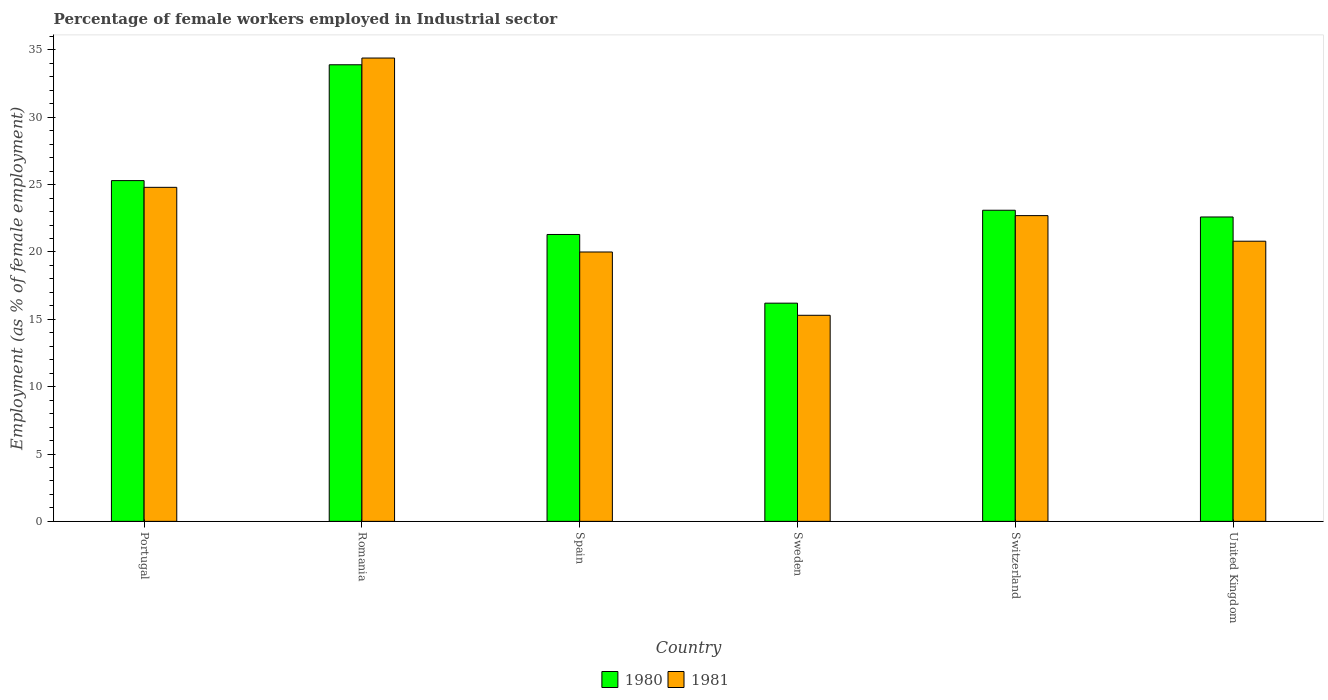How many groups of bars are there?
Provide a succinct answer. 6. Are the number of bars per tick equal to the number of legend labels?
Offer a terse response. Yes. Are the number of bars on each tick of the X-axis equal?
Ensure brevity in your answer.  Yes. What is the label of the 5th group of bars from the left?
Provide a succinct answer. Switzerland. What is the percentage of females employed in Industrial sector in 1980 in Romania?
Make the answer very short. 33.9. Across all countries, what is the maximum percentage of females employed in Industrial sector in 1981?
Make the answer very short. 34.4. Across all countries, what is the minimum percentage of females employed in Industrial sector in 1981?
Your answer should be compact. 15.3. In which country was the percentage of females employed in Industrial sector in 1980 maximum?
Keep it short and to the point. Romania. In which country was the percentage of females employed in Industrial sector in 1981 minimum?
Your answer should be very brief. Sweden. What is the total percentage of females employed in Industrial sector in 1981 in the graph?
Give a very brief answer. 138. What is the difference between the percentage of females employed in Industrial sector in 1981 in Portugal and that in Spain?
Make the answer very short. 4.8. What is the difference between the percentage of females employed in Industrial sector in 1981 in Sweden and the percentage of females employed in Industrial sector in 1980 in Romania?
Offer a very short reply. -18.6. What is the average percentage of females employed in Industrial sector in 1980 per country?
Your answer should be very brief. 23.73. What is the difference between the percentage of females employed in Industrial sector of/in 1980 and percentage of females employed in Industrial sector of/in 1981 in Sweden?
Keep it short and to the point. 0.9. In how many countries, is the percentage of females employed in Industrial sector in 1980 greater than 8 %?
Your response must be concise. 6. What is the ratio of the percentage of females employed in Industrial sector in 1981 in Portugal to that in Spain?
Offer a very short reply. 1.24. Is the percentage of females employed in Industrial sector in 1980 in Sweden less than that in United Kingdom?
Your answer should be very brief. Yes. What is the difference between the highest and the second highest percentage of females employed in Industrial sector in 1980?
Your response must be concise. 8.6. What is the difference between the highest and the lowest percentage of females employed in Industrial sector in 1980?
Make the answer very short. 17.7. Is the sum of the percentage of females employed in Industrial sector in 1980 in Portugal and Switzerland greater than the maximum percentage of females employed in Industrial sector in 1981 across all countries?
Your response must be concise. Yes. What does the 1st bar from the right in Switzerland represents?
Your answer should be very brief. 1981. Are all the bars in the graph horizontal?
Offer a terse response. No. How many countries are there in the graph?
Offer a terse response. 6. What is the difference between two consecutive major ticks on the Y-axis?
Your response must be concise. 5. Does the graph contain grids?
Provide a succinct answer. No. Where does the legend appear in the graph?
Make the answer very short. Bottom center. How are the legend labels stacked?
Provide a short and direct response. Horizontal. What is the title of the graph?
Provide a short and direct response. Percentage of female workers employed in Industrial sector. What is the label or title of the Y-axis?
Your response must be concise. Employment (as % of female employment). What is the Employment (as % of female employment) in 1980 in Portugal?
Make the answer very short. 25.3. What is the Employment (as % of female employment) in 1981 in Portugal?
Your response must be concise. 24.8. What is the Employment (as % of female employment) of 1980 in Romania?
Provide a succinct answer. 33.9. What is the Employment (as % of female employment) of 1981 in Romania?
Provide a short and direct response. 34.4. What is the Employment (as % of female employment) of 1980 in Spain?
Offer a very short reply. 21.3. What is the Employment (as % of female employment) in 1980 in Sweden?
Offer a very short reply. 16.2. What is the Employment (as % of female employment) in 1981 in Sweden?
Your answer should be very brief. 15.3. What is the Employment (as % of female employment) of 1980 in Switzerland?
Provide a short and direct response. 23.1. What is the Employment (as % of female employment) in 1981 in Switzerland?
Provide a short and direct response. 22.7. What is the Employment (as % of female employment) in 1980 in United Kingdom?
Your answer should be compact. 22.6. What is the Employment (as % of female employment) in 1981 in United Kingdom?
Your answer should be compact. 20.8. Across all countries, what is the maximum Employment (as % of female employment) in 1980?
Ensure brevity in your answer.  33.9. Across all countries, what is the maximum Employment (as % of female employment) in 1981?
Your answer should be very brief. 34.4. Across all countries, what is the minimum Employment (as % of female employment) in 1980?
Provide a succinct answer. 16.2. Across all countries, what is the minimum Employment (as % of female employment) in 1981?
Offer a terse response. 15.3. What is the total Employment (as % of female employment) of 1980 in the graph?
Provide a short and direct response. 142.4. What is the total Employment (as % of female employment) in 1981 in the graph?
Provide a short and direct response. 138. What is the difference between the Employment (as % of female employment) of 1980 in Portugal and that in Romania?
Provide a succinct answer. -8.6. What is the difference between the Employment (as % of female employment) of 1981 in Portugal and that in Romania?
Give a very brief answer. -9.6. What is the difference between the Employment (as % of female employment) of 1980 in Portugal and that in Sweden?
Offer a terse response. 9.1. What is the difference between the Employment (as % of female employment) of 1980 in Portugal and that in Switzerland?
Your answer should be compact. 2.2. What is the difference between the Employment (as % of female employment) in 1981 in Portugal and that in United Kingdom?
Offer a terse response. 4. What is the difference between the Employment (as % of female employment) of 1980 in Romania and that in Spain?
Ensure brevity in your answer.  12.6. What is the difference between the Employment (as % of female employment) of 1980 in Romania and that in Sweden?
Your response must be concise. 17.7. What is the difference between the Employment (as % of female employment) in 1981 in Romania and that in Sweden?
Ensure brevity in your answer.  19.1. What is the difference between the Employment (as % of female employment) of 1980 in Romania and that in Switzerland?
Give a very brief answer. 10.8. What is the difference between the Employment (as % of female employment) in 1981 in Romania and that in Switzerland?
Offer a terse response. 11.7. What is the difference between the Employment (as % of female employment) in 1980 in Romania and that in United Kingdom?
Offer a very short reply. 11.3. What is the difference between the Employment (as % of female employment) in 1981 in Romania and that in United Kingdom?
Keep it short and to the point. 13.6. What is the difference between the Employment (as % of female employment) in 1980 in Spain and that in Sweden?
Provide a short and direct response. 5.1. What is the difference between the Employment (as % of female employment) of 1981 in Spain and that in Sweden?
Provide a succinct answer. 4.7. What is the difference between the Employment (as % of female employment) of 1980 in Spain and that in Switzerland?
Your answer should be compact. -1.8. What is the difference between the Employment (as % of female employment) in 1981 in Spain and that in United Kingdom?
Ensure brevity in your answer.  -0.8. What is the difference between the Employment (as % of female employment) in 1980 in Sweden and that in Switzerland?
Your answer should be very brief. -6.9. What is the difference between the Employment (as % of female employment) of 1981 in Sweden and that in United Kingdom?
Offer a terse response. -5.5. What is the difference between the Employment (as % of female employment) in 1981 in Switzerland and that in United Kingdom?
Offer a very short reply. 1.9. What is the difference between the Employment (as % of female employment) of 1980 in Portugal and the Employment (as % of female employment) of 1981 in United Kingdom?
Your answer should be compact. 4.5. What is the difference between the Employment (as % of female employment) in 1980 in Romania and the Employment (as % of female employment) in 1981 in Spain?
Your response must be concise. 13.9. What is the difference between the Employment (as % of female employment) of 1980 in Romania and the Employment (as % of female employment) of 1981 in Switzerland?
Your response must be concise. 11.2. What is the difference between the Employment (as % of female employment) of 1980 in Romania and the Employment (as % of female employment) of 1981 in United Kingdom?
Offer a very short reply. 13.1. What is the difference between the Employment (as % of female employment) of 1980 in Spain and the Employment (as % of female employment) of 1981 in Switzerland?
Provide a short and direct response. -1.4. What is the difference between the Employment (as % of female employment) in 1980 in Spain and the Employment (as % of female employment) in 1981 in United Kingdom?
Provide a short and direct response. 0.5. What is the difference between the Employment (as % of female employment) in 1980 in Sweden and the Employment (as % of female employment) in 1981 in United Kingdom?
Give a very brief answer. -4.6. What is the difference between the Employment (as % of female employment) of 1980 in Switzerland and the Employment (as % of female employment) of 1981 in United Kingdom?
Ensure brevity in your answer.  2.3. What is the average Employment (as % of female employment) of 1980 per country?
Offer a terse response. 23.73. What is the average Employment (as % of female employment) of 1981 per country?
Provide a succinct answer. 23. What is the difference between the Employment (as % of female employment) of 1980 and Employment (as % of female employment) of 1981 in Spain?
Provide a short and direct response. 1.3. What is the difference between the Employment (as % of female employment) of 1980 and Employment (as % of female employment) of 1981 in Switzerland?
Provide a short and direct response. 0.4. What is the ratio of the Employment (as % of female employment) of 1980 in Portugal to that in Romania?
Your answer should be compact. 0.75. What is the ratio of the Employment (as % of female employment) of 1981 in Portugal to that in Romania?
Keep it short and to the point. 0.72. What is the ratio of the Employment (as % of female employment) of 1980 in Portugal to that in Spain?
Offer a terse response. 1.19. What is the ratio of the Employment (as % of female employment) in 1981 in Portugal to that in Spain?
Ensure brevity in your answer.  1.24. What is the ratio of the Employment (as % of female employment) of 1980 in Portugal to that in Sweden?
Make the answer very short. 1.56. What is the ratio of the Employment (as % of female employment) in 1981 in Portugal to that in Sweden?
Make the answer very short. 1.62. What is the ratio of the Employment (as % of female employment) in 1980 in Portugal to that in Switzerland?
Provide a succinct answer. 1.1. What is the ratio of the Employment (as % of female employment) in 1981 in Portugal to that in Switzerland?
Your response must be concise. 1.09. What is the ratio of the Employment (as % of female employment) in 1980 in Portugal to that in United Kingdom?
Provide a short and direct response. 1.12. What is the ratio of the Employment (as % of female employment) in 1981 in Portugal to that in United Kingdom?
Provide a short and direct response. 1.19. What is the ratio of the Employment (as % of female employment) in 1980 in Romania to that in Spain?
Ensure brevity in your answer.  1.59. What is the ratio of the Employment (as % of female employment) in 1981 in Romania to that in Spain?
Give a very brief answer. 1.72. What is the ratio of the Employment (as % of female employment) in 1980 in Romania to that in Sweden?
Ensure brevity in your answer.  2.09. What is the ratio of the Employment (as % of female employment) in 1981 in Romania to that in Sweden?
Your response must be concise. 2.25. What is the ratio of the Employment (as % of female employment) of 1980 in Romania to that in Switzerland?
Ensure brevity in your answer.  1.47. What is the ratio of the Employment (as % of female employment) in 1981 in Romania to that in Switzerland?
Give a very brief answer. 1.52. What is the ratio of the Employment (as % of female employment) in 1980 in Romania to that in United Kingdom?
Your answer should be very brief. 1.5. What is the ratio of the Employment (as % of female employment) of 1981 in Romania to that in United Kingdom?
Make the answer very short. 1.65. What is the ratio of the Employment (as % of female employment) in 1980 in Spain to that in Sweden?
Provide a succinct answer. 1.31. What is the ratio of the Employment (as % of female employment) in 1981 in Spain to that in Sweden?
Your answer should be compact. 1.31. What is the ratio of the Employment (as % of female employment) in 1980 in Spain to that in Switzerland?
Give a very brief answer. 0.92. What is the ratio of the Employment (as % of female employment) in 1981 in Spain to that in Switzerland?
Keep it short and to the point. 0.88. What is the ratio of the Employment (as % of female employment) in 1980 in Spain to that in United Kingdom?
Keep it short and to the point. 0.94. What is the ratio of the Employment (as % of female employment) of 1981 in Spain to that in United Kingdom?
Offer a terse response. 0.96. What is the ratio of the Employment (as % of female employment) in 1980 in Sweden to that in Switzerland?
Offer a very short reply. 0.7. What is the ratio of the Employment (as % of female employment) in 1981 in Sweden to that in Switzerland?
Ensure brevity in your answer.  0.67. What is the ratio of the Employment (as % of female employment) of 1980 in Sweden to that in United Kingdom?
Keep it short and to the point. 0.72. What is the ratio of the Employment (as % of female employment) of 1981 in Sweden to that in United Kingdom?
Offer a terse response. 0.74. What is the ratio of the Employment (as % of female employment) of 1980 in Switzerland to that in United Kingdom?
Make the answer very short. 1.02. What is the ratio of the Employment (as % of female employment) of 1981 in Switzerland to that in United Kingdom?
Your answer should be very brief. 1.09. What is the difference between the highest and the second highest Employment (as % of female employment) in 1980?
Keep it short and to the point. 8.6. What is the difference between the highest and the lowest Employment (as % of female employment) in 1981?
Offer a very short reply. 19.1. 